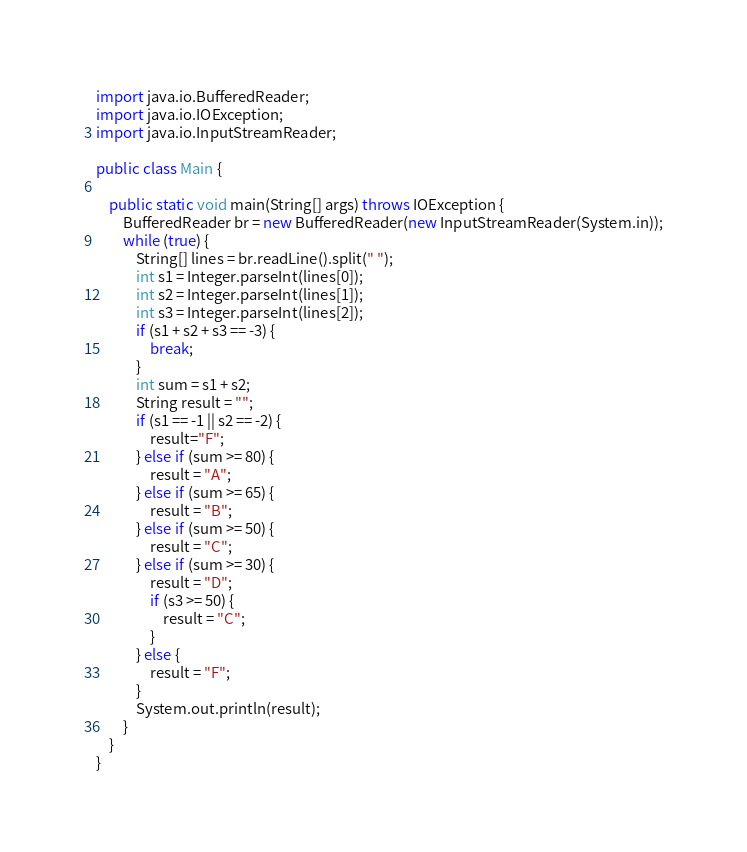<code> <loc_0><loc_0><loc_500><loc_500><_Java_>import java.io.BufferedReader;
import java.io.IOException;
import java.io.InputStreamReader;

public class Main {

    public static void main(String[] args) throws IOException {
        BufferedReader br = new BufferedReader(new InputStreamReader(System.in));
        while (true) {
            String[] lines = br.readLine().split(" ");
            int s1 = Integer.parseInt(lines[0]);
            int s2 = Integer.parseInt(lines[1]);
            int s3 = Integer.parseInt(lines[2]);
            if (s1 + s2 + s3 == -3) {
                break;
            }
            int sum = s1 + s2;
            String result = "";
            if (s1 == -1 || s2 == -2) {
                result="F";
            } else if (sum >= 80) {
                result = "A";
            } else if (sum >= 65) {
                result = "B";
            } else if (sum >= 50) {
                result = "C";
            } else if (sum >= 30) {
                result = "D";
                if (s3 >= 50) {
                    result = "C";
                }
            } else {
                result = "F";
            }
            System.out.println(result);
        }
    }
}</code> 